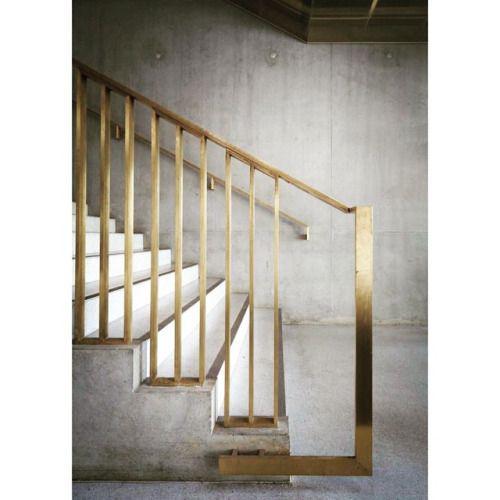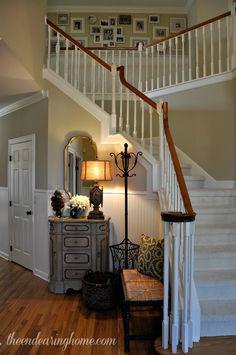The first image is the image on the left, the second image is the image on the right. Assess this claim about the two images: "In at least  one image there is a winding stair care that is both white and wood brown.". Correct or not? Answer yes or no. Yes. The first image is the image on the left, the second image is the image on the right. Evaluate the accuracy of this statement regarding the images: "The right image shows a staircase with white 'spindles' and a brown handrail that zigs and zags instead of ascending with no turns.". Is it true? Answer yes or no. Yes. 